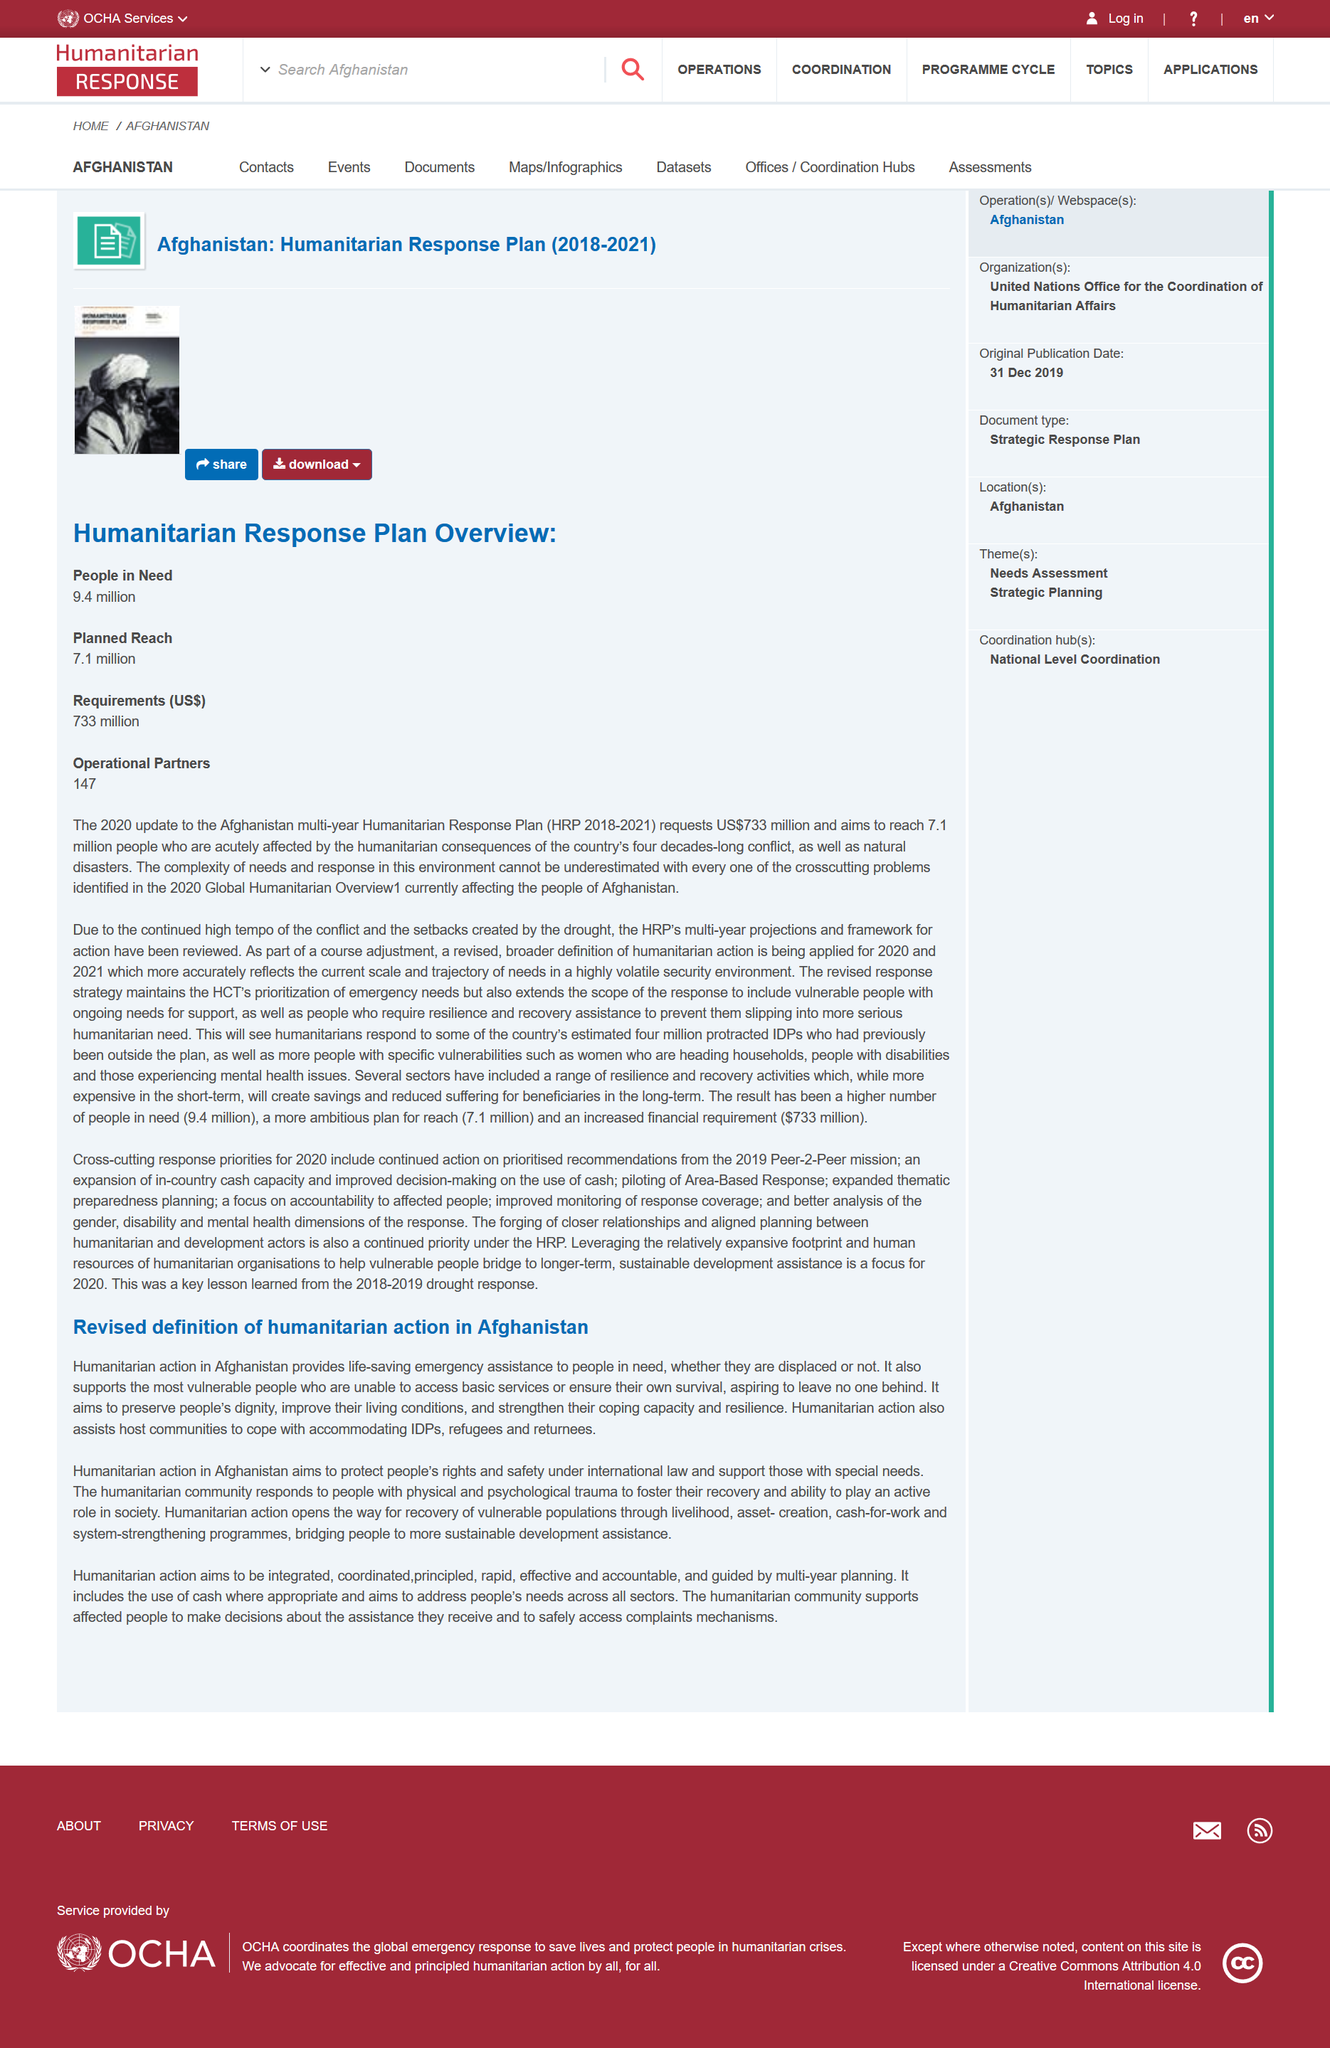Identify some key points in this picture. The country of concern in this piece is Afghanistan. The Afghanistan multi-year Humanitarian Response Plan includes 147 operational partners, which are actively working towards addressing the humanitarian needs of the country. The planned reach of the Afghanistan multi-year Humanitarian Response Plan is 7.1 million people. Ninety-four million people are in need of humanitarian response in the current plan. This is not the first definition of humanitarian action in Afghanistan. Instead, it is a revised definition that has been developed for use in the country. 